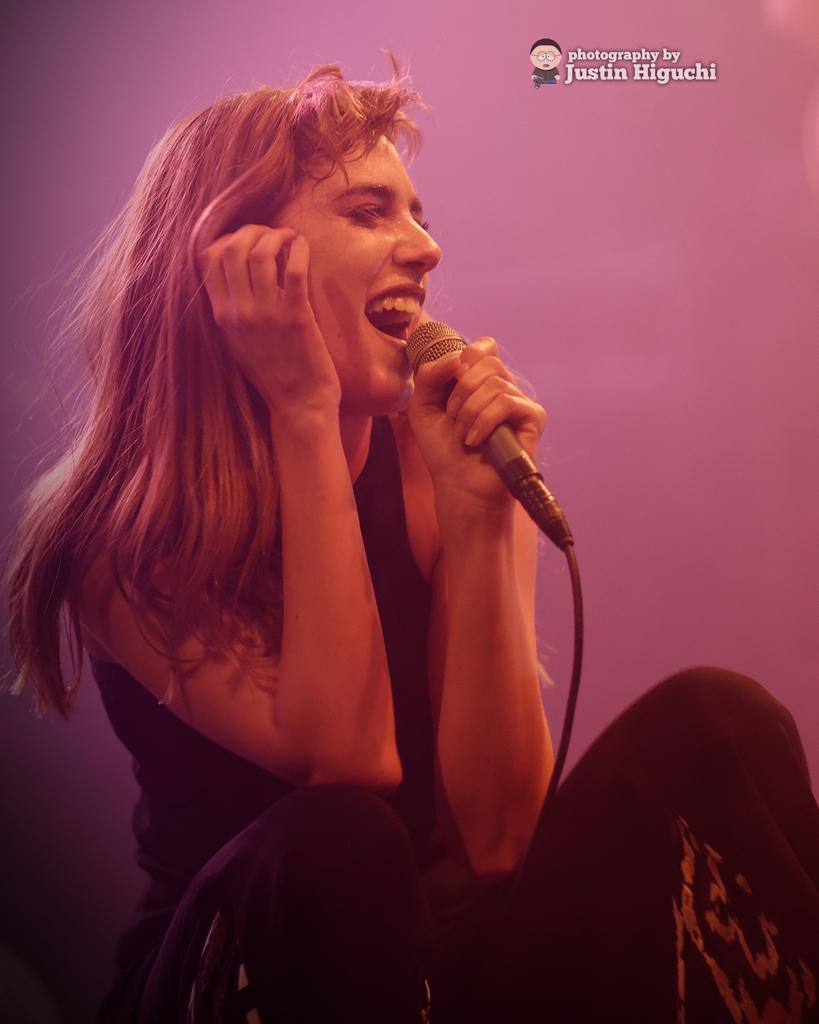Who is the main subject in the image? There is a woman in the image. What is the woman doing in the image? The woman is sitting in the image. What object is the woman holding in her hand? The woman is holding a mic in one of her hands. What type of basin is visible in the image? There is no basin present in the image. How does the woman sort items in the image? The image does not show the woman sorting items, as she is holding a mic and sitting. 